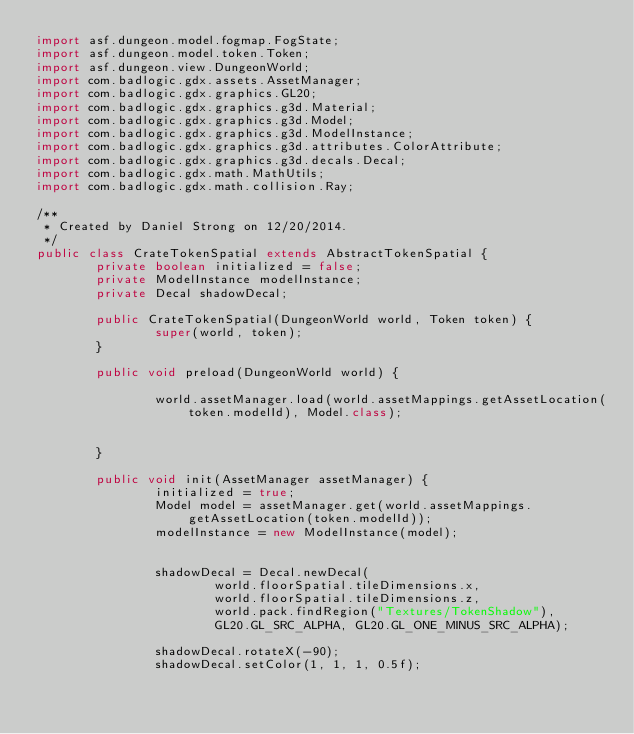Convert code to text. <code><loc_0><loc_0><loc_500><loc_500><_Java_>import asf.dungeon.model.fogmap.FogState;
import asf.dungeon.model.token.Token;
import asf.dungeon.view.DungeonWorld;
import com.badlogic.gdx.assets.AssetManager;
import com.badlogic.gdx.graphics.GL20;
import com.badlogic.gdx.graphics.g3d.Material;
import com.badlogic.gdx.graphics.g3d.Model;
import com.badlogic.gdx.graphics.g3d.ModelInstance;
import com.badlogic.gdx.graphics.g3d.attributes.ColorAttribute;
import com.badlogic.gdx.graphics.g3d.decals.Decal;
import com.badlogic.gdx.math.MathUtils;
import com.badlogic.gdx.math.collision.Ray;

/**
 * Created by Daniel Strong on 12/20/2014.
 */
public class CrateTokenSpatial extends AbstractTokenSpatial {
        private boolean initialized = false;
        private ModelInstance modelInstance;
        private Decal shadowDecal;

        public CrateTokenSpatial(DungeonWorld world, Token token) {
                super(world, token);
        }

        public void preload(DungeonWorld world) {

                world.assetManager.load(world.assetMappings.getAssetLocation(token.modelId), Model.class);


        }

        public void init(AssetManager assetManager) {
                initialized = true;
                Model model = assetManager.get(world.assetMappings.getAssetLocation(token.modelId));
                modelInstance = new ModelInstance(model);


                shadowDecal = Decal.newDecal(
                        world.floorSpatial.tileDimensions.x,
                        world.floorSpatial.tileDimensions.z,
                        world.pack.findRegion("Textures/TokenShadow"),
                        GL20.GL_SRC_ALPHA, GL20.GL_ONE_MINUS_SRC_ALPHA);

                shadowDecal.rotateX(-90);
                shadowDecal.setColor(1, 1, 1, 0.5f);
</code> 